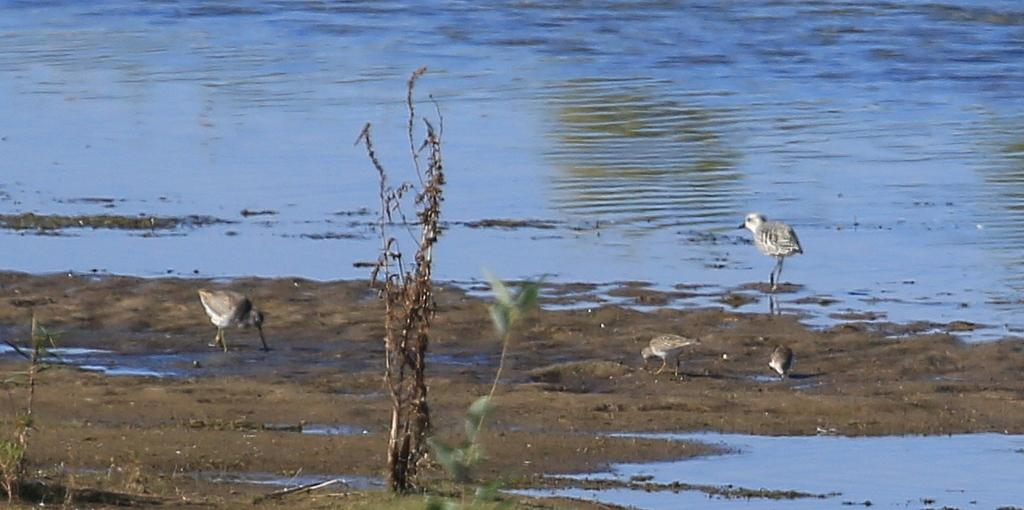What type of animals can be seen on the ground in the image? There are birds on the ground in the image. What is the primary feature visible in the background of the image? There is a water body in the image. What type of vegetation is present in the image? There are plants in the image. What type of party is happening near the water body in the image? There is no party present in the image; it features birds, a water body, and plants. Can you tell me how many grandfathers are visible in the image? There are no grandfathers present in the image. 